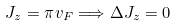Convert formula to latex. <formula><loc_0><loc_0><loc_500><loc_500>J _ { z } = \pi v _ { F } \Longrightarrow \Delta J _ { z } = 0</formula> 